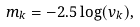Convert formula to latex. <formula><loc_0><loc_0><loc_500><loc_500>m _ { k } = - 2 . 5 \log ( v _ { k } ) ,</formula> 